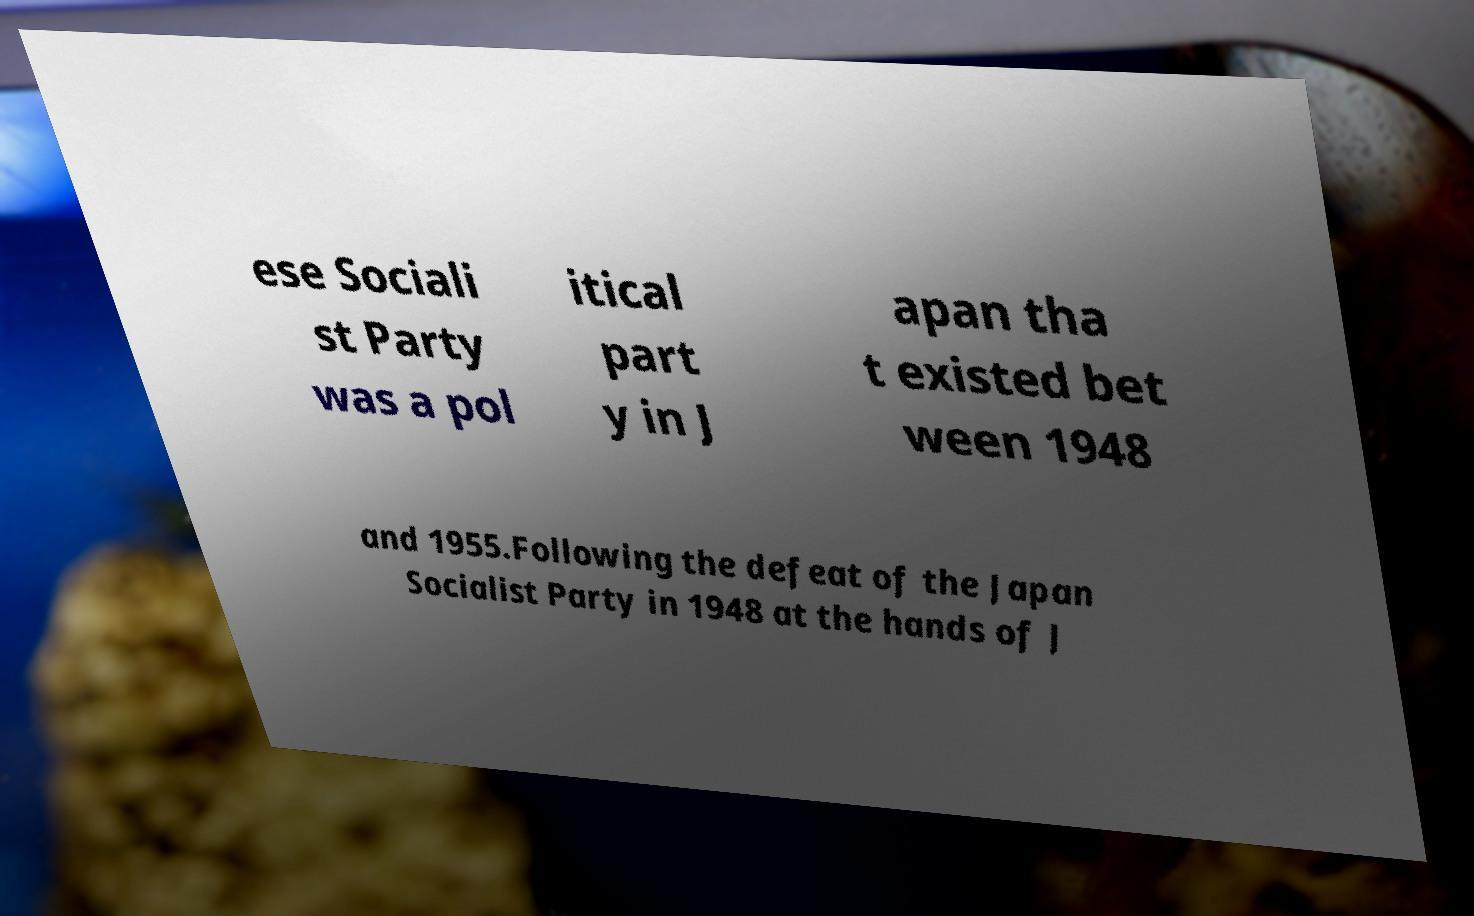For documentation purposes, I need the text within this image transcribed. Could you provide that? ese Sociali st Party was a pol itical part y in J apan tha t existed bet ween 1948 and 1955.Following the defeat of the Japan Socialist Party in 1948 at the hands of J 